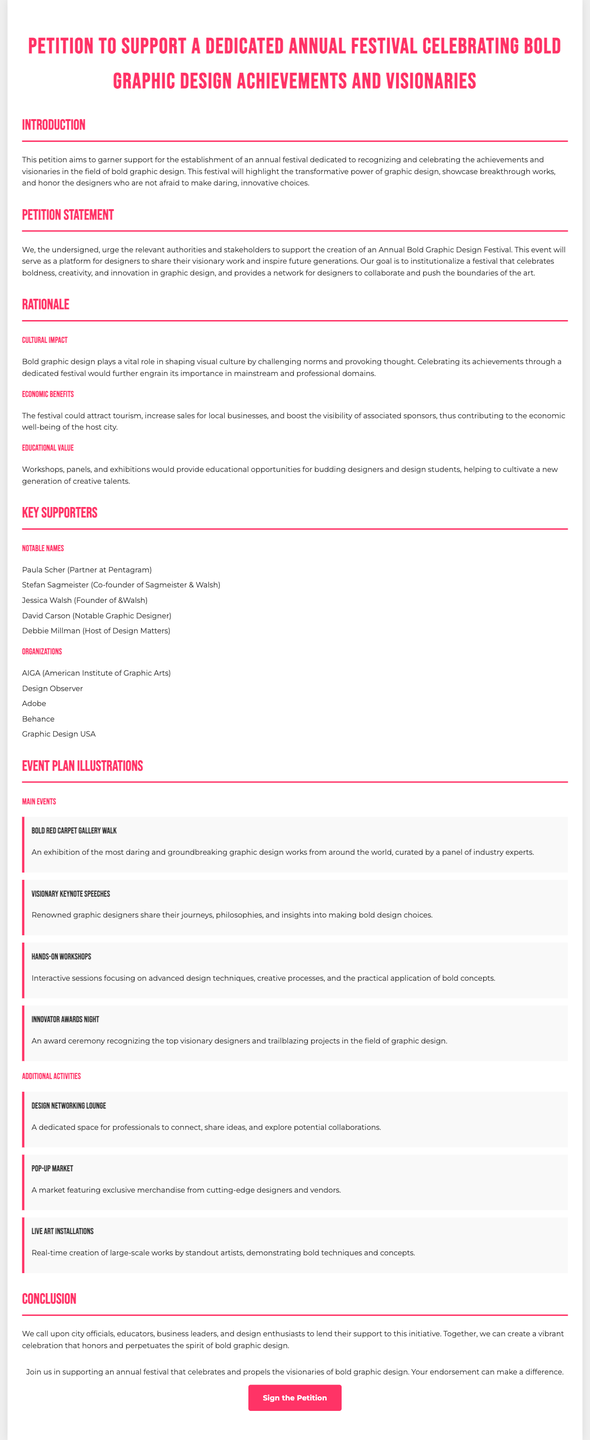What is the title of the petition? The title is the main header of the document, which outlines the purpose of the petition.
Answer: Petition to Support a Dedicated Annual Festival Celebrating Bold Graphic Design Achievements and Visionaries Who is one of the notable supporters mentioned? The document lists notable supporters under the "Key Supporters" section, providing specific names.
Answer: Paula Scher What is one of the economic benefits mentioned? The rationale section discusses various benefits, including those related to tourism and local businesses.
Answer: Attract tourism What type of event is the "Innovator Awards Night"? The document details different events planned for the festival, explaining their nature and purpose.
Answer: An award ceremony How many main events are listed in the event plan? The event plan section lists specific main events, providing a count of them for clarity.
Answer: Four What educational value does the festival aim to provide? The rationale details the festival's goals in terms of education for budding designers and students.
Answer: Educational opportunities What color is the festival's main theme highlighted in the document? The document uses specific colors for headings and accents throughout, reflecting the theme of creativity.
Answer: #ff3366 What is the call to action at the end of the petition? The conclusion section includes a specific phrase urging participation in support of the petition.
Answer: Join us in supporting an annual festival 